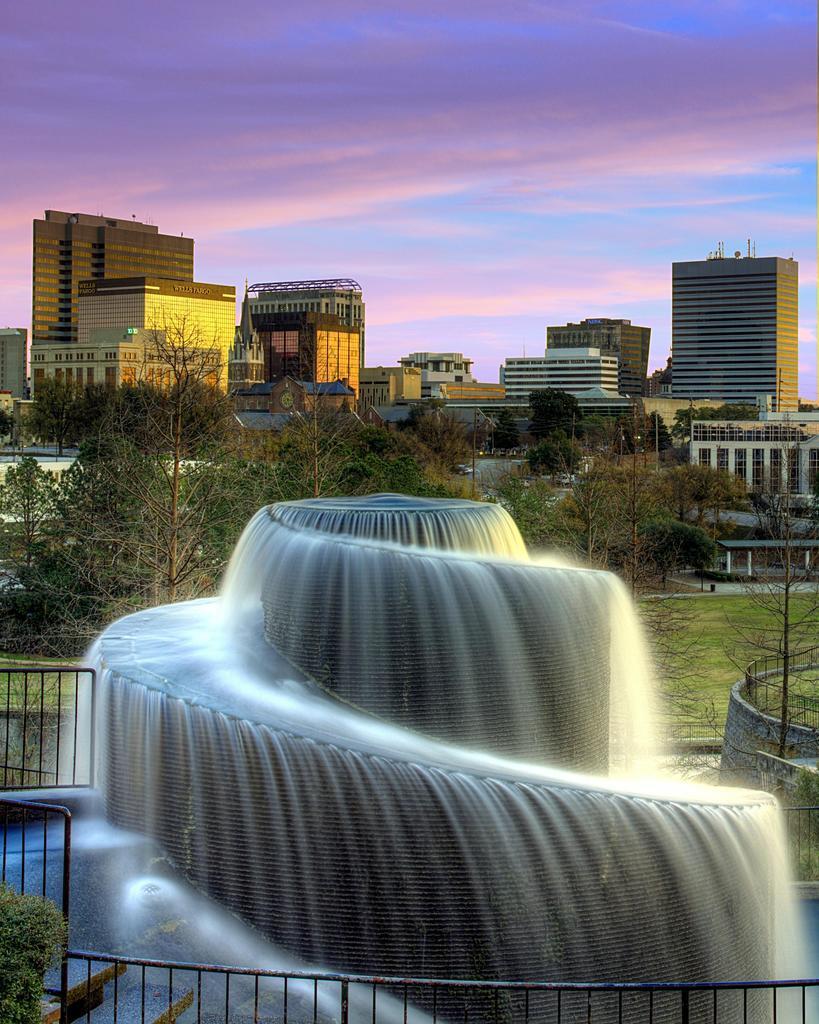Describe this image in one or two sentences. In this picture we can see a spiral fountain of water surrounded by gates, grass, trees and buildings. The sky is purple. 